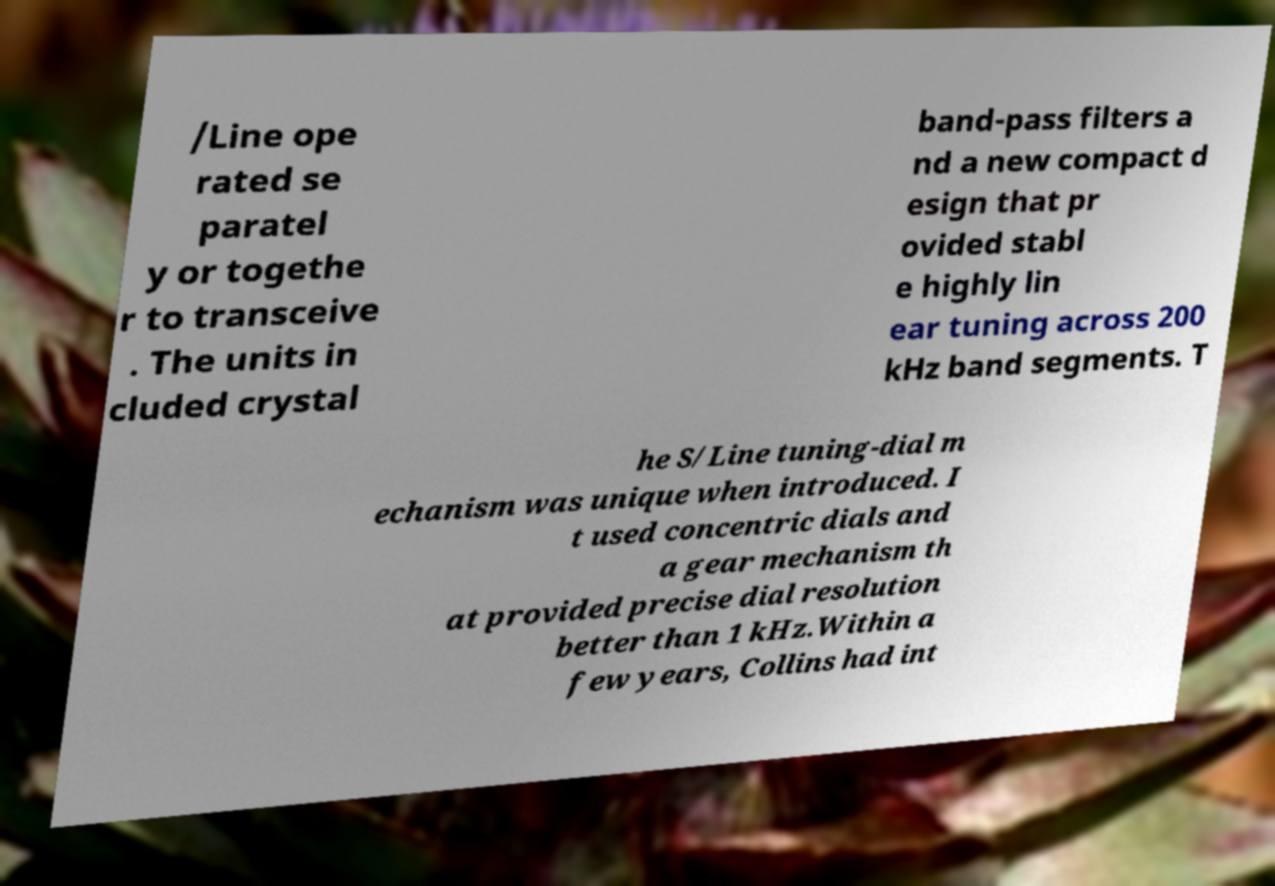There's text embedded in this image that I need extracted. Can you transcribe it verbatim? /Line ope rated se paratel y or togethe r to transceive . The units in cluded crystal band-pass filters a nd a new compact d esign that pr ovided stabl e highly lin ear tuning across 200 kHz band segments. T he S/Line tuning-dial m echanism was unique when introduced. I t used concentric dials and a gear mechanism th at provided precise dial resolution better than 1 kHz.Within a few years, Collins had int 